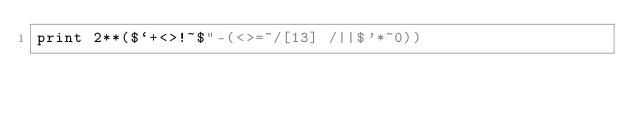Convert code to text. <code><loc_0><loc_0><loc_500><loc_500><_Perl_>print 2**($`+<>!~$"-(<>=~/[13] /||$'*~0))</code> 